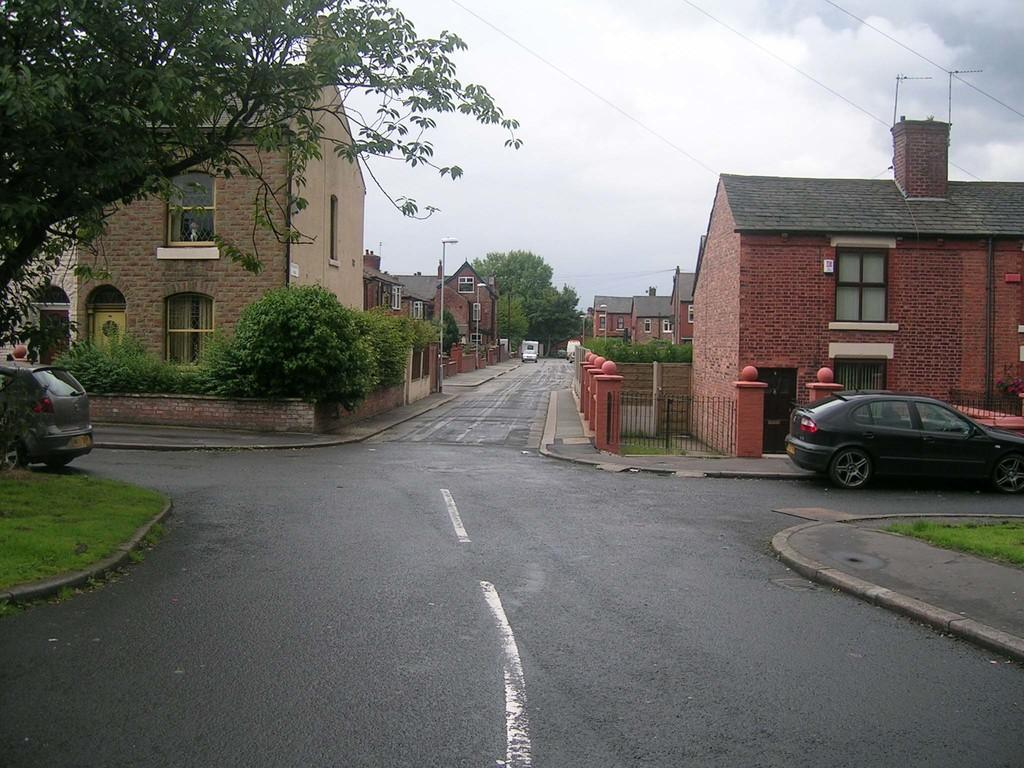What type of vegetation can be seen in the image? There is grass and plants in the image. What type of man-made structures are present in the image? There are cars, buildings, and street lamps in the image. What architectural feature can be seen on the buildings? Windows are present in the image on the buildings. What is visible at the top of the image? The sky is visible at the top of the image, and clouds are present in the sky. How many frogs are sitting on the street lamps in the image? There are no frogs present in the image; it features grass, plants, cars, buildings, street lamps, and windows. What type of fiction is being read by the clouds in the image? There are no books or reading material present in the image, and the clouds are not depicted as engaging in any activity. 